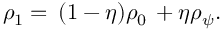<formula> <loc_0><loc_0><loc_500><loc_500>\begin{array} { r } { \rho _ { 1 } = \, ( 1 - \eta ) \rho _ { 0 } \, + \eta \rho _ { \psi } . } \end{array}</formula> 